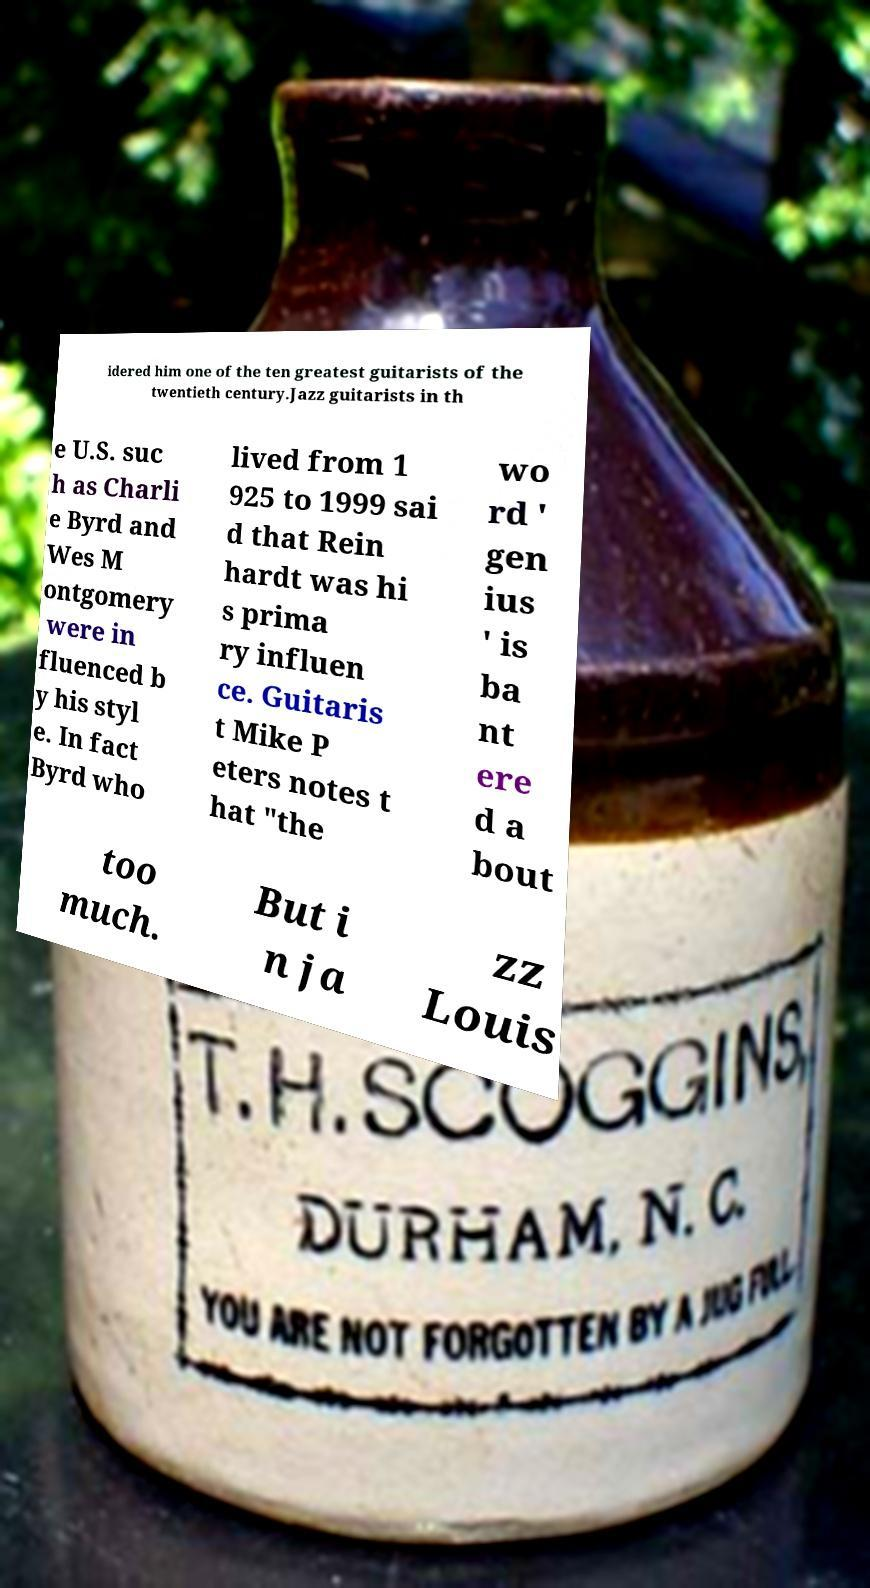Please read and relay the text visible in this image. What does it say? idered him one of the ten greatest guitarists of the twentieth century.Jazz guitarists in th e U.S. suc h as Charli e Byrd and Wes M ontgomery were in fluenced b y his styl e. In fact Byrd who lived from 1 925 to 1999 sai d that Rein hardt was hi s prima ry influen ce. Guitaris t Mike P eters notes t hat "the wo rd ' gen ius ' is ba nt ere d a bout too much. But i n ja zz Louis 